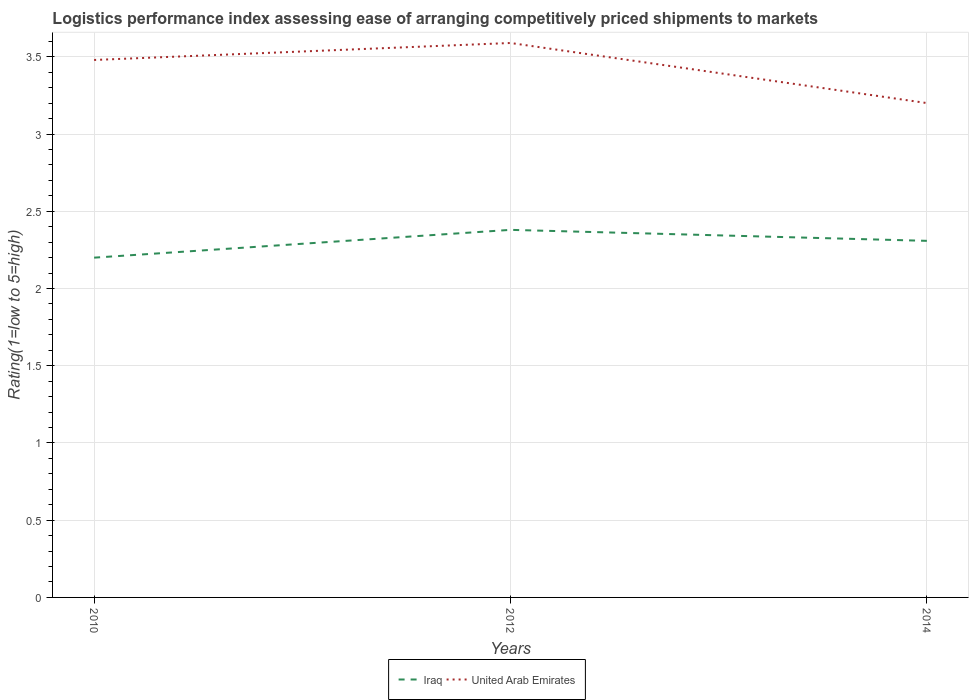Does the line corresponding to United Arab Emirates intersect with the line corresponding to Iraq?
Offer a very short reply. No. Is the number of lines equal to the number of legend labels?
Provide a short and direct response. Yes. Across all years, what is the maximum Logistic performance index in United Arab Emirates?
Provide a short and direct response. 3.2. What is the total Logistic performance index in Iraq in the graph?
Offer a terse response. 0.07. What is the difference between the highest and the second highest Logistic performance index in United Arab Emirates?
Keep it short and to the point. 0.39. How many lines are there?
Keep it short and to the point. 2. How many years are there in the graph?
Offer a terse response. 3. Does the graph contain any zero values?
Make the answer very short. No. Does the graph contain grids?
Offer a terse response. Yes. How are the legend labels stacked?
Give a very brief answer. Horizontal. What is the title of the graph?
Keep it short and to the point. Logistics performance index assessing ease of arranging competitively priced shipments to markets. What is the label or title of the X-axis?
Provide a succinct answer. Years. What is the label or title of the Y-axis?
Your answer should be compact. Rating(1=low to 5=high). What is the Rating(1=low to 5=high) of United Arab Emirates in 2010?
Keep it short and to the point. 3.48. What is the Rating(1=low to 5=high) in Iraq in 2012?
Offer a very short reply. 2.38. What is the Rating(1=low to 5=high) of United Arab Emirates in 2012?
Provide a short and direct response. 3.59. What is the Rating(1=low to 5=high) in Iraq in 2014?
Ensure brevity in your answer.  2.31. What is the Rating(1=low to 5=high) in United Arab Emirates in 2014?
Give a very brief answer. 3.2. Across all years, what is the maximum Rating(1=low to 5=high) in Iraq?
Provide a succinct answer. 2.38. Across all years, what is the maximum Rating(1=low to 5=high) of United Arab Emirates?
Ensure brevity in your answer.  3.59. Across all years, what is the minimum Rating(1=low to 5=high) of United Arab Emirates?
Provide a succinct answer. 3.2. What is the total Rating(1=low to 5=high) of Iraq in the graph?
Provide a succinct answer. 6.89. What is the total Rating(1=low to 5=high) of United Arab Emirates in the graph?
Make the answer very short. 10.27. What is the difference between the Rating(1=low to 5=high) in Iraq in 2010 and that in 2012?
Your answer should be very brief. -0.18. What is the difference between the Rating(1=low to 5=high) in United Arab Emirates in 2010 and that in 2012?
Your answer should be very brief. -0.11. What is the difference between the Rating(1=low to 5=high) of Iraq in 2010 and that in 2014?
Ensure brevity in your answer.  -0.11. What is the difference between the Rating(1=low to 5=high) in United Arab Emirates in 2010 and that in 2014?
Your answer should be very brief. 0.28. What is the difference between the Rating(1=low to 5=high) of Iraq in 2012 and that in 2014?
Offer a very short reply. 0.07. What is the difference between the Rating(1=low to 5=high) in United Arab Emirates in 2012 and that in 2014?
Provide a succinct answer. 0.39. What is the difference between the Rating(1=low to 5=high) in Iraq in 2010 and the Rating(1=low to 5=high) in United Arab Emirates in 2012?
Offer a terse response. -1.39. What is the difference between the Rating(1=low to 5=high) in Iraq in 2010 and the Rating(1=low to 5=high) in United Arab Emirates in 2014?
Your answer should be very brief. -1. What is the difference between the Rating(1=low to 5=high) of Iraq in 2012 and the Rating(1=low to 5=high) of United Arab Emirates in 2014?
Your answer should be compact. -0.82. What is the average Rating(1=low to 5=high) in Iraq per year?
Your response must be concise. 2.3. What is the average Rating(1=low to 5=high) in United Arab Emirates per year?
Provide a short and direct response. 3.42. In the year 2010, what is the difference between the Rating(1=low to 5=high) of Iraq and Rating(1=low to 5=high) of United Arab Emirates?
Give a very brief answer. -1.28. In the year 2012, what is the difference between the Rating(1=low to 5=high) of Iraq and Rating(1=low to 5=high) of United Arab Emirates?
Your response must be concise. -1.21. In the year 2014, what is the difference between the Rating(1=low to 5=high) in Iraq and Rating(1=low to 5=high) in United Arab Emirates?
Offer a very short reply. -0.89. What is the ratio of the Rating(1=low to 5=high) in Iraq in 2010 to that in 2012?
Provide a succinct answer. 0.92. What is the ratio of the Rating(1=low to 5=high) in United Arab Emirates in 2010 to that in 2012?
Offer a very short reply. 0.97. What is the ratio of the Rating(1=low to 5=high) in Iraq in 2010 to that in 2014?
Your answer should be compact. 0.95. What is the ratio of the Rating(1=low to 5=high) of United Arab Emirates in 2010 to that in 2014?
Keep it short and to the point. 1.09. What is the ratio of the Rating(1=low to 5=high) in Iraq in 2012 to that in 2014?
Offer a terse response. 1.03. What is the ratio of the Rating(1=low to 5=high) in United Arab Emirates in 2012 to that in 2014?
Your response must be concise. 1.12. What is the difference between the highest and the second highest Rating(1=low to 5=high) of Iraq?
Offer a very short reply. 0.07. What is the difference between the highest and the second highest Rating(1=low to 5=high) of United Arab Emirates?
Offer a terse response. 0.11. What is the difference between the highest and the lowest Rating(1=low to 5=high) in Iraq?
Make the answer very short. 0.18. What is the difference between the highest and the lowest Rating(1=low to 5=high) of United Arab Emirates?
Keep it short and to the point. 0.39. 